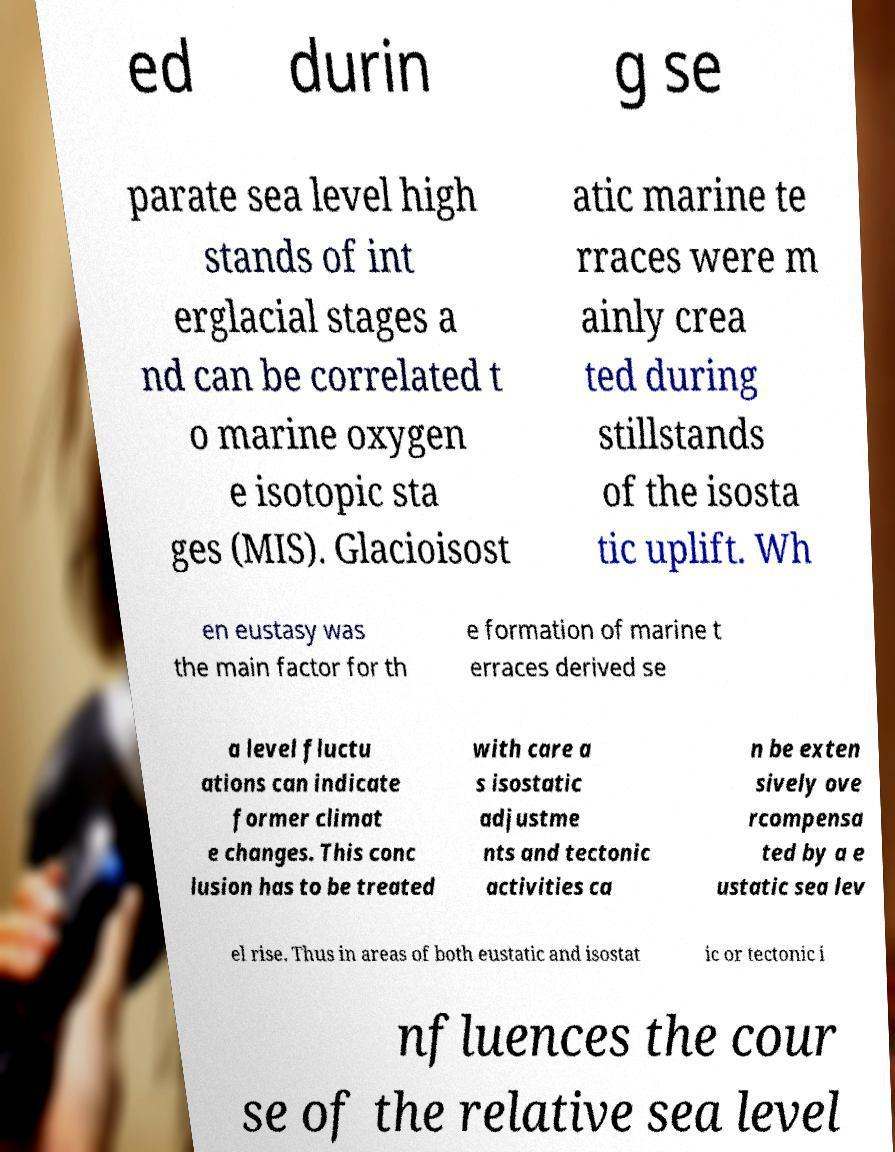Can you accurately transcribe the text from the provided image for me? ed durin g se parate sea level high stands of int erglacial stages a nd can be correlated t o marine oxygen e isotopic sta ges (MIS). Glacioisost atic marine te rraces were m ainly crea ted during stillstands of the isosta tic uplift. Wh en eustasy was the main factor for th e formation of marine t erraces derived se a level fluctu ations can indicate former climat e changes. This conc lusion has to be treated with care a s isostatic adjustme nts and tectonic activities ca n be exten sively ove rcompensa ted by a e ustatic sea lev el rise. Thus in areas of both eustatic and isostat ic or tectonic i nfluences the cour se of the relative sea level 